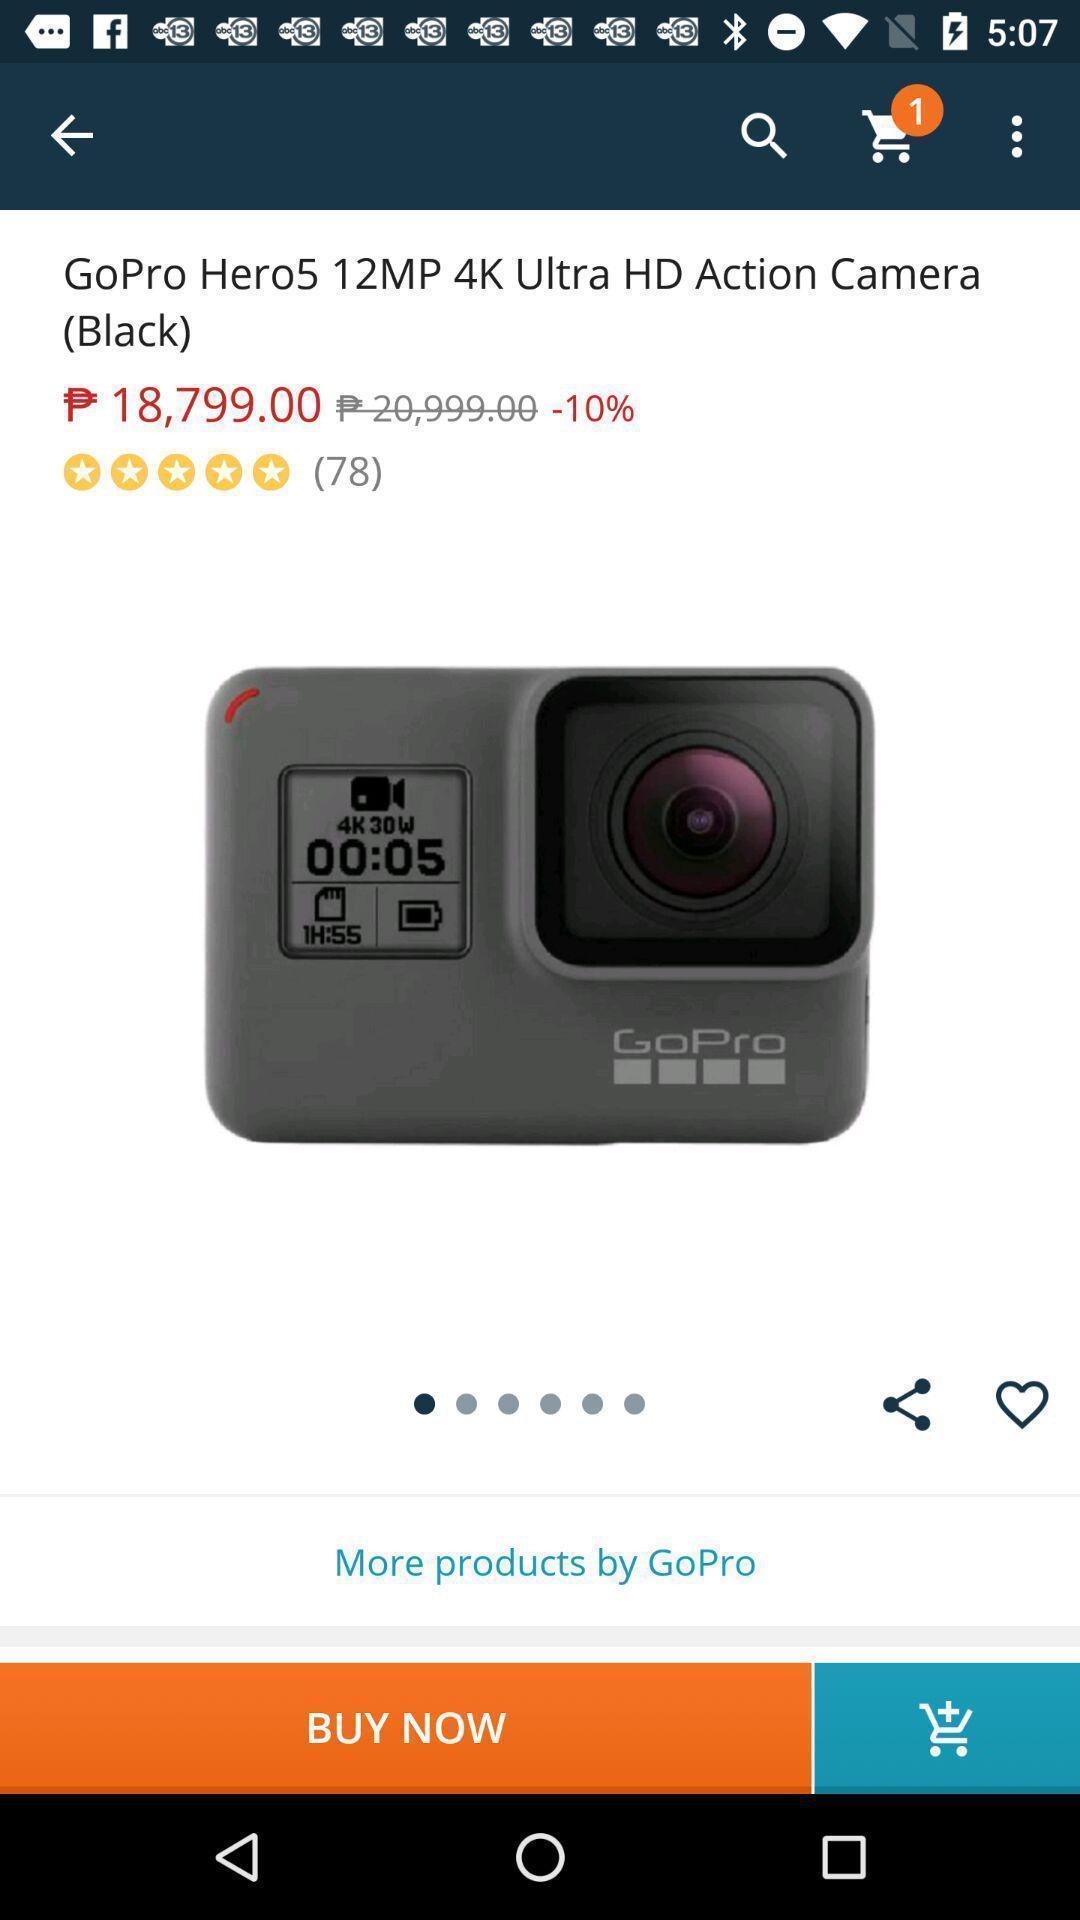What details can you identify in this image? Page showing the product with its price. 